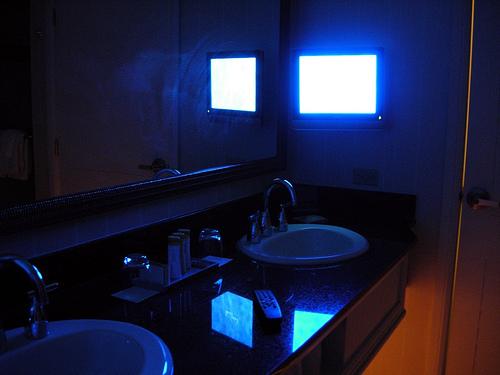What is room is the remote laying on the counter?
Concise answer only. Bathroom. Are the lights on?
Short answer required. No. Is there artificial light in this room?
Give a very brief answer. No. How many windows are reflected?
Give a very brief answer. 1. 